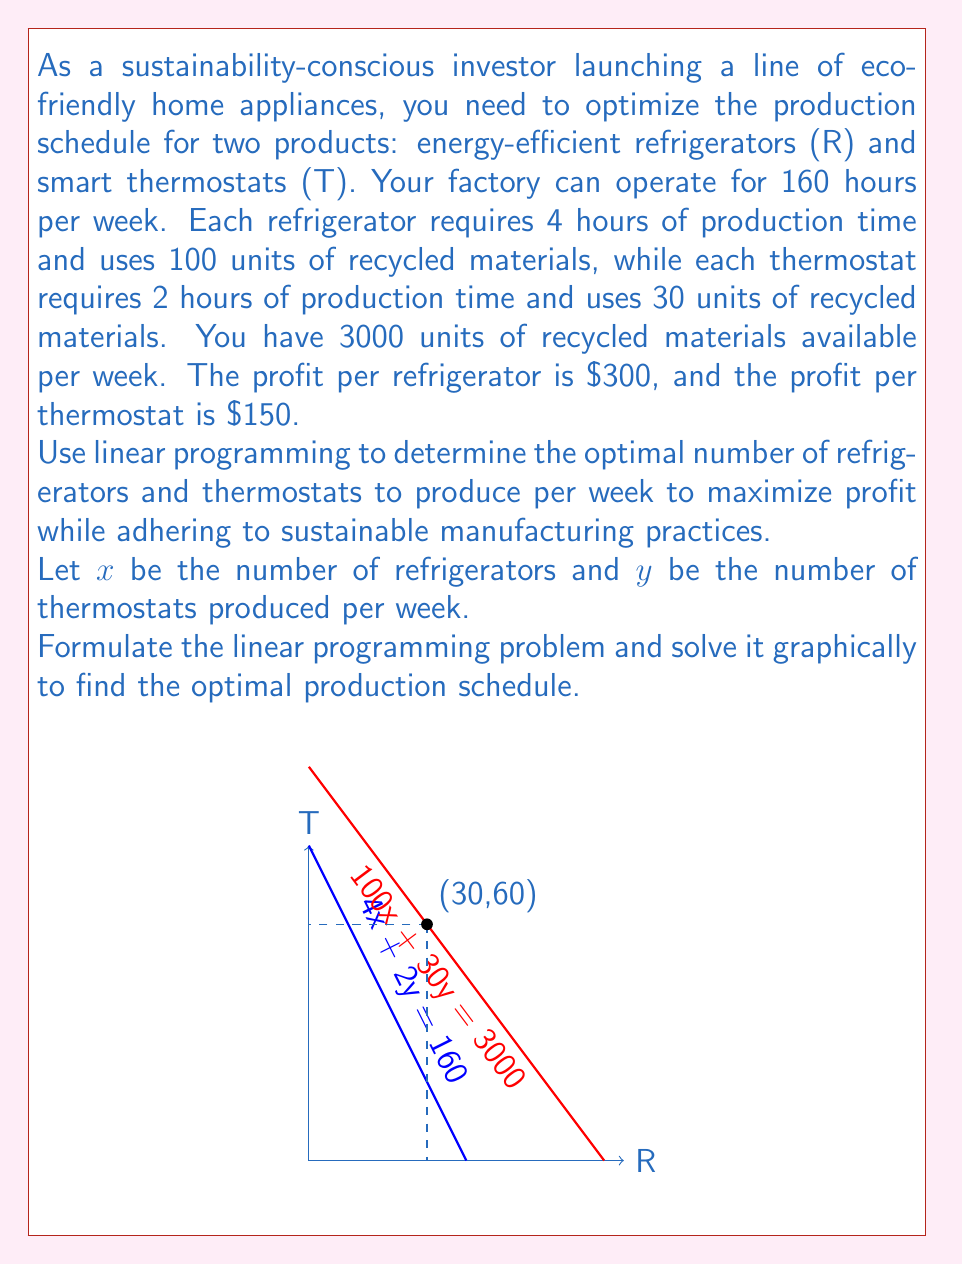Provide a solution to this math problem. Let's solve this problem step by step:

1) First, we need to formulate the linear programming problem:

   Maximize: $P = 300x + 150y$ (Profit function)

   Subject to:
   $4x + 2y \leq 160$ (Time constraint)
   $100x + 30y \leq 3000$ (Material constraint)
   $x \geq 0, y \geq 0$ (Non-negativity constraints)

2) Now, let's plot the constraints:

   For $4x + 2y = 160$:
   When $x = 0, y = 80$
   When $y = 0, x = 40$

   For $100x + 30y = 3000$:
   When $x = 0, y = 100$
   When $y = 0, x = 30$

3) The feasible region is the area bounded by these lines and the axes.

4) The optimal solution will be at one of the corner points of this feasible region. The corner points are:
   (0, 0), (0, 80), (30, 0), and the intersection of the two constraint lines.

5) To find the intersection point, solve:
   $4x + 2y = 160$
   $100x + 30y = 3000$

   Multiplying the first equation by 25 and subtracting from the second:
   $100x + 50y = 4000$
   $100x + 30y = 3000$
   $20y = 1000$
   $y = 50$

   Substituting back:
   $4x + 2(50) = 160$
   $4x = 60$
   $x = 15$

   So, the intersection point is (15, 50).

6) Now, evaluate the profit function at each corner point:
   P(0, 0) = 0
   P(0, 80) = 12,000
   P(30, 0) = 9,000
   P(15, 50) = 12,000

7) The maximum profit occurs at two points: (0, 80) and (15, 50). However, (15, 50) is a more balanced production schedule and utilizes both product lines, which is likely preferable for a new business.

Therefore, the optimal production schedule is to produce 15 refrigerators and 50 thermostats per week.
Answer: 15 refrigerators and 50 thermostats per week 